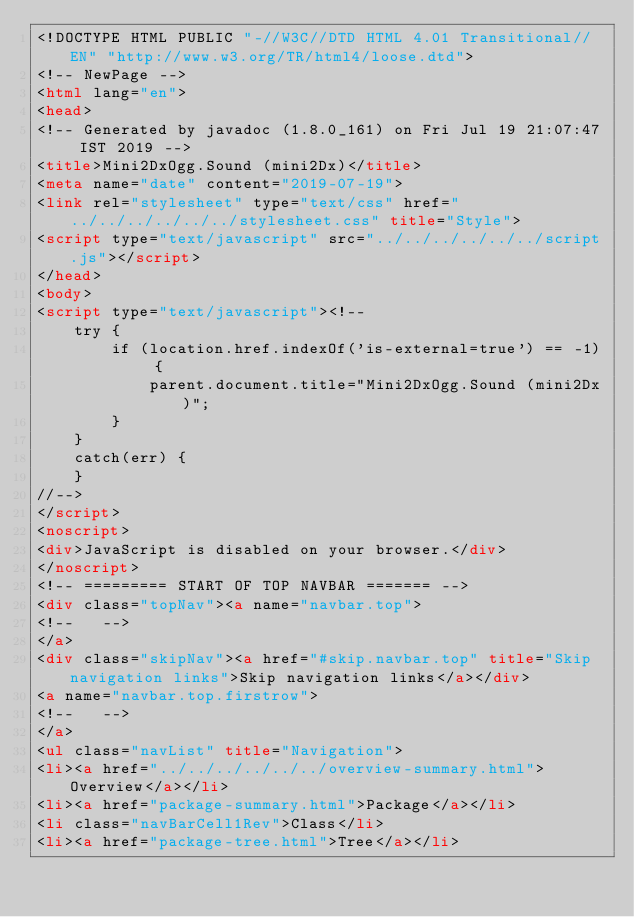Convert code to text. <code><loc_0><loc_0><loc_500><loc_500><_HTML_><!DOCTYPE HTML PUBLIC "-//W3C//DTD HTML 4.01 Transitional//EN" "http://www.w3.org/TR/html4/loose.dtd">
<!-- NewPage -->
<html lang="en">
<head>
<!-- Generated by javadoc (1.8.0_161) on Fri Jul 19 21:07:47 IST 2019 -->
<title>Mini2DxOgg.Sound (mini2Dx)</title>
<meta name="date" content="2019-07-19">
<link rel="stylesheet" type="text/css" href="../../../../../../stylesheet.css" title="Style">
<script type="text/javascript" src="../../../../../../script.js"></script>
</head>
<body>
<script type="text/javascript"><!--
    try {
        if (location.href.indexOf('is-external=true') == -1) {
            parent.document.title="Mini2DxOgg.Sound (mini2Dx)";
        }
    }
    catch(err) {
    }
//-->
</script>
<noscript>
<div>JavaScript is disabled on your browser.</div>
</noscript>
<!-- ========= START OF TOP NAVBAR ======= -->
<div class="topNav"><a name="navbar.top">
<!--   -->
</a>
<div class="skipNav"><a href="#skip.navbar.top" title="Skip navigation links">Skip navigation links</a></div>
<a name="navbar.top.firstrow">
<!--   -->
</a>
<ul class="navList" title="Navigation">
<li><a href="../../../../../../overview-summary.html">Overview</a></li>
<li><a href="package-summary.html">Package</a></li>
<li class="navBarCell1Rev">Class</li>
<li><a href="package-tree.html">Tree</a></li></code> 